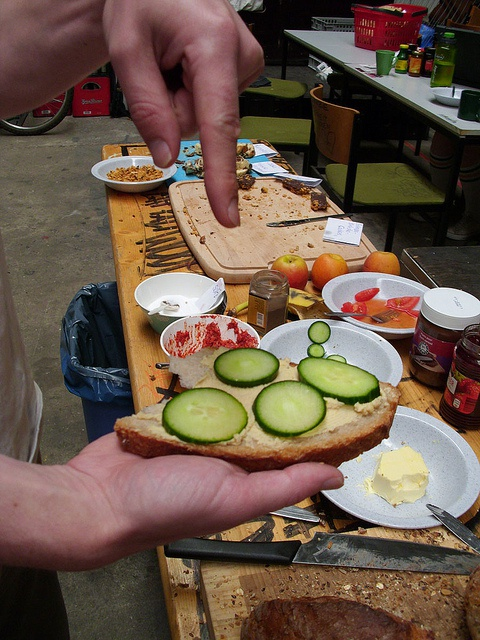Describe the objects in this image and their specific colors. I can see dining table in brown, black, maroon, tan, and lightgray tones, people in brown, maroon, and black tones, sandwich in brown, tan, maroon, black, and olive tones, bowl in brown, lightgray, darkgray, and khaki tones, and dining table in brown, black, darkgray, gray, and darkgreen tones in this image. 